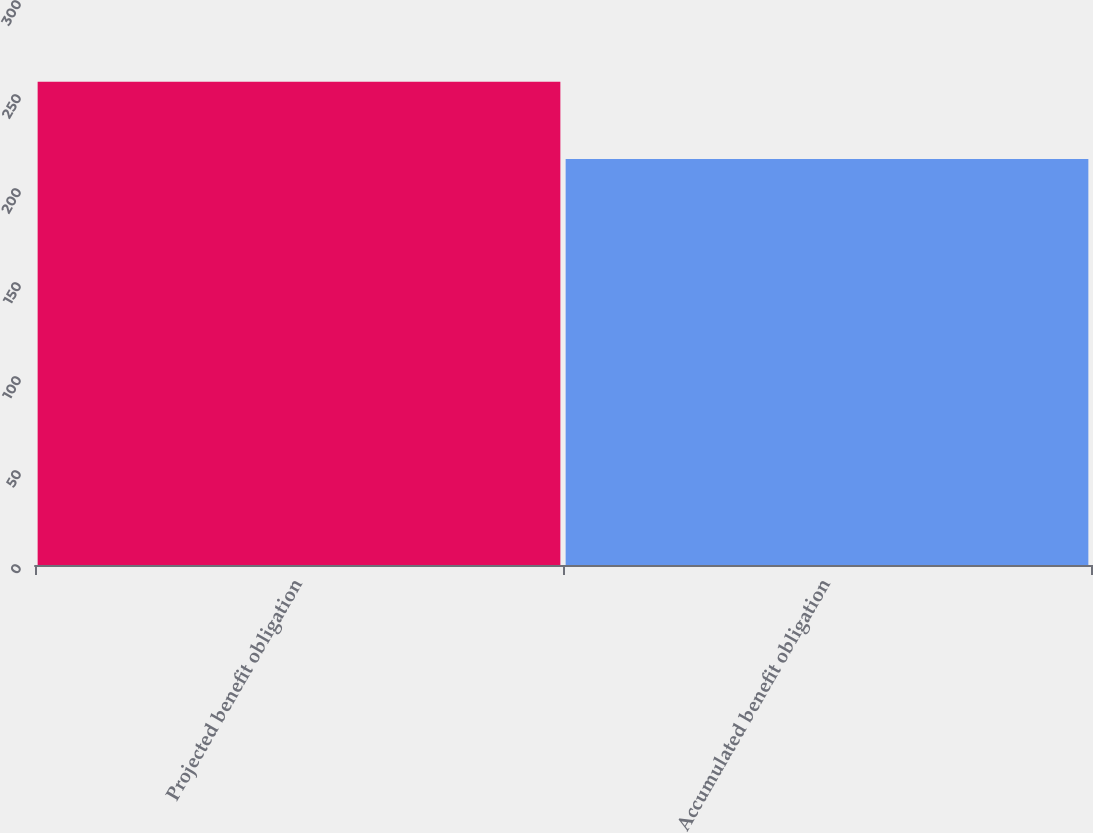Convert chart to OTSL. <chart><loc_0><loc_0><loc_500><loc_500><bar_chart><fcel>Projected benefit obligation<fcel>Accumulated benefit obligation<nl><fcel>257<fcel>216<nl></chart> 